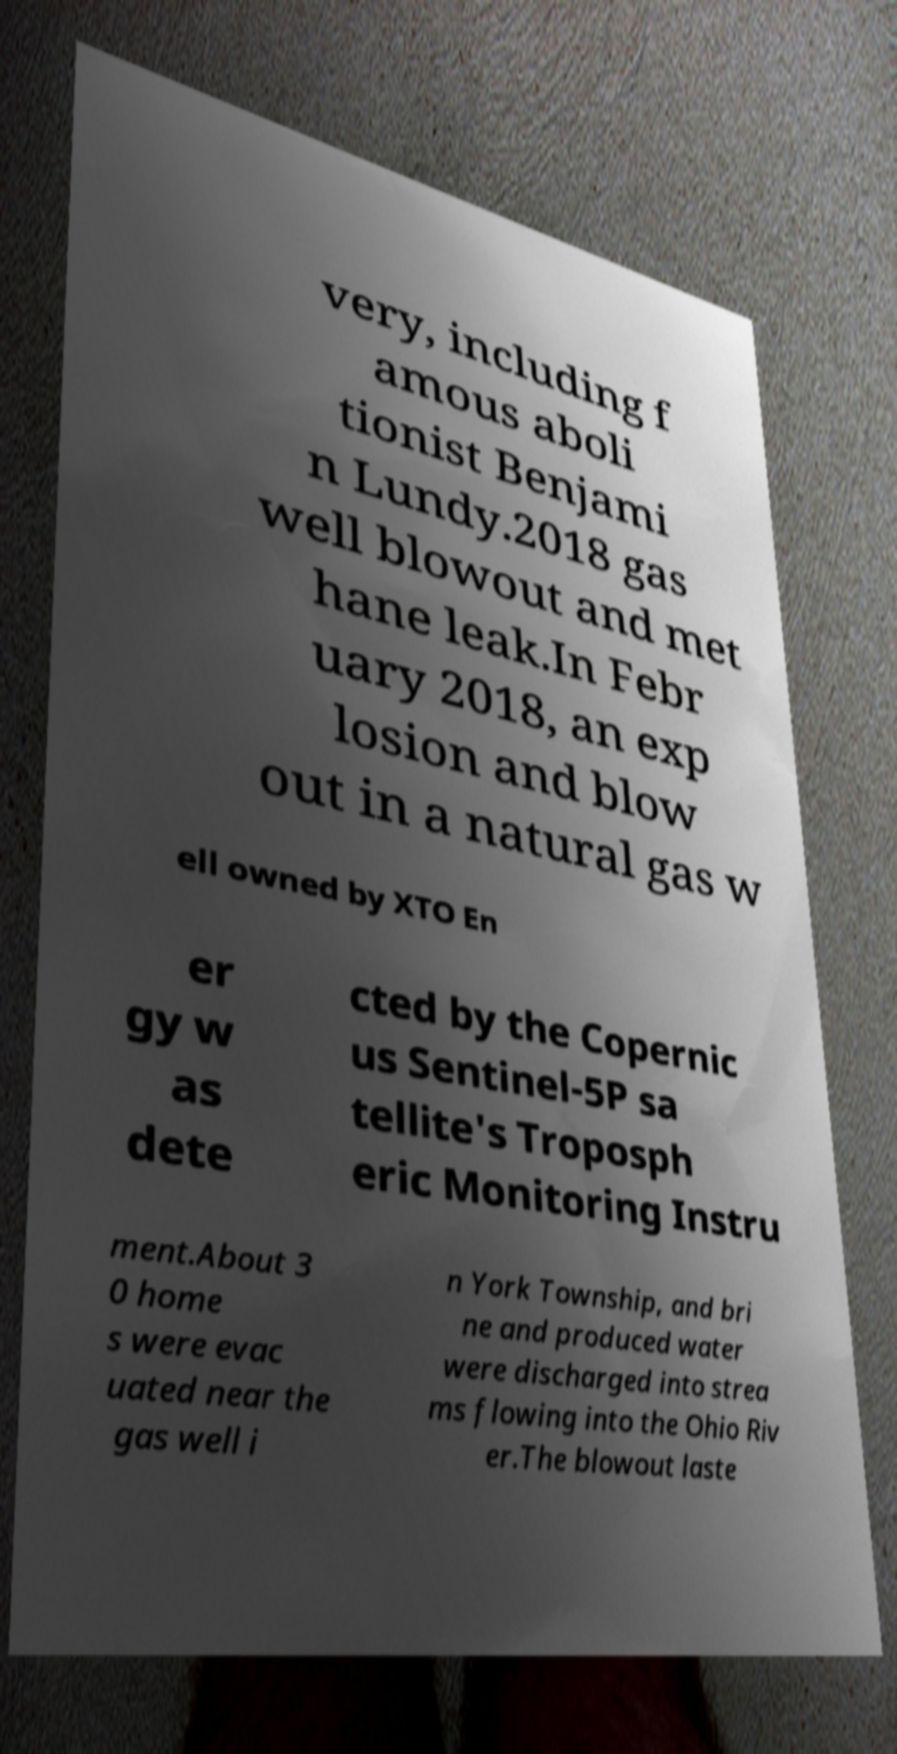Can you accurately transcribe the text from the provided image for me? very, including f amous aboli tionist Benjami n Lundy.2018 gas well blowout and met hane leak.In Febr uary 2018, an exp losion and blow out in a natural gas w ell owned by XTO En er gy w as dete cted by the Copernic us Sentinel-5P sa tellite's Troposph eric Monitoring Instru ment.About 3 0 home s were evac uated near the gas well i n York Township, and bri ne and produced water were discharged into strea ms flowing into the Ohio Riv er.The blowout laste 